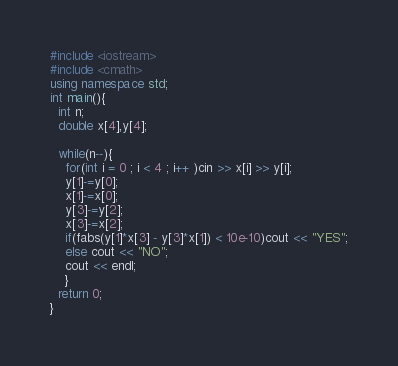Convert code to text. <code><loc_0><loc_0><loc_500><loc_500><_C++_>#include <iostream>
#include <cmath>
using namespace std;
int main(){
  int n;
  double x[4],y[4];

  while(n--){
    for(int i = 0 ; i < 4 ; i++ )cin >> x[i] >> y[i];
    y[1]-=y[0];
    x[1]-=x[0];
    y[3]-=y[2];
    x[3]-=x[2];
    if(fabs(y[1]*x[3] - y[3]*x[1]) < 10e-10)cout << "YES";
    else cout << "NO";
    cout << endl;
    }
  return 0;
}</code> 